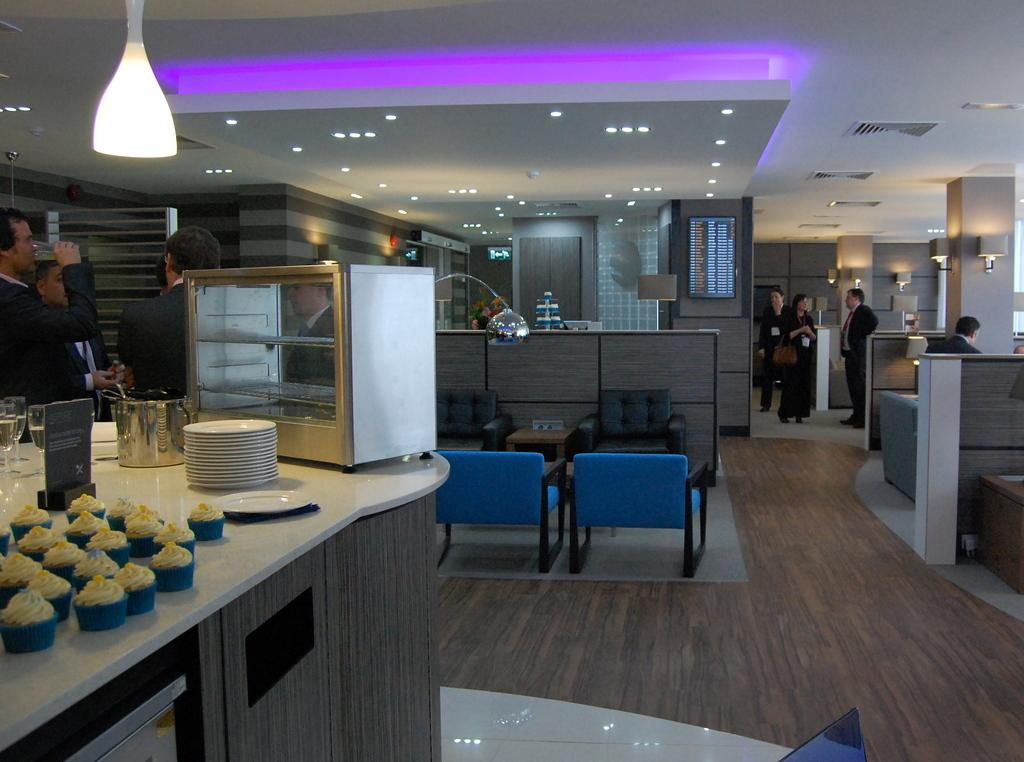How many people can be seen in the image? There are many people standing in the image. What type of furniture is present in the image? There is a sofa chair in the image. What type of food is visible in the image? There are plates, cupcakes, and wine glasses in the image. Where is the cracker located in the image? There is no cracker present in the image. What type of bomb can be seen in the image? There is no bomb present in the image. 